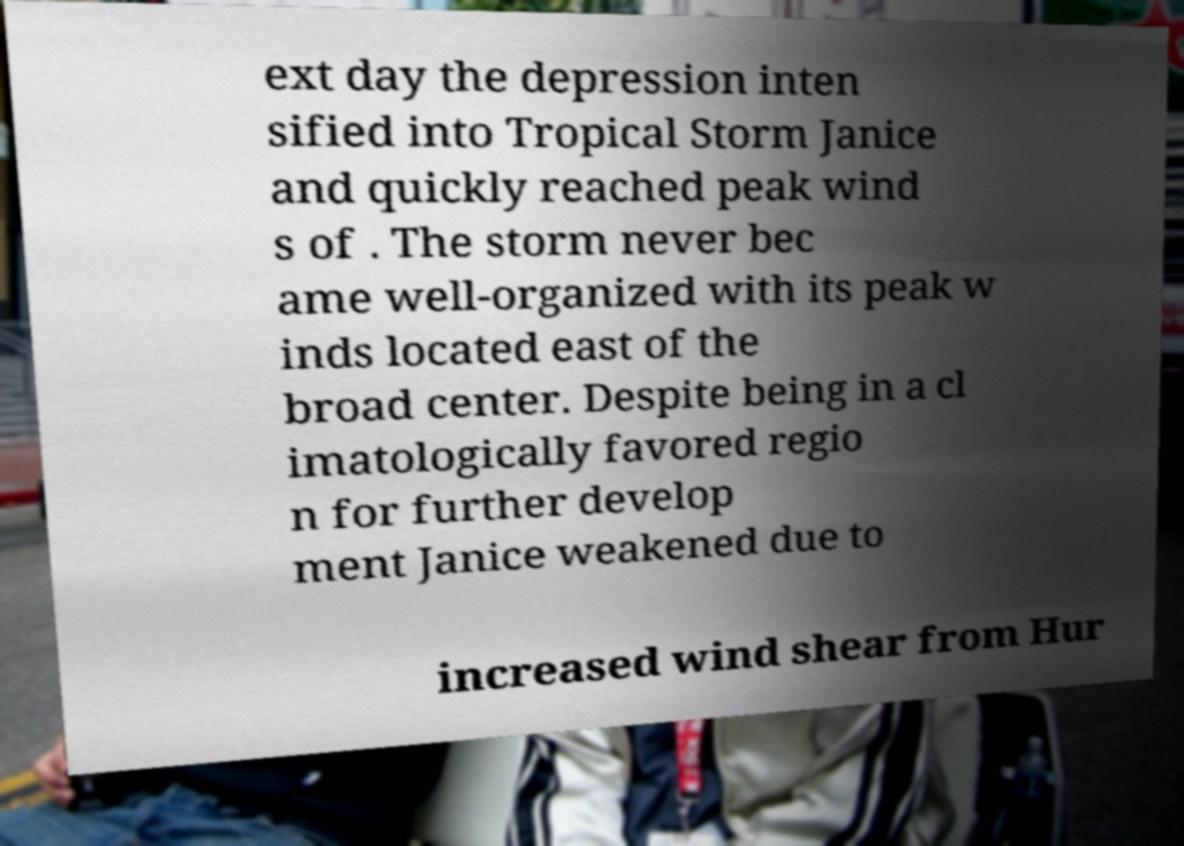Could you extract and type out the text from this image? ext day the depression inten sified into Tropical Storm Janice and quickly reached peak wind s of . The storm never bec ame well-organized with its peak w inds located east of the broad center. Despite being in a cl imatologically favored regio n for further develop ment Janice weakened due to increased wind shear from Hur 